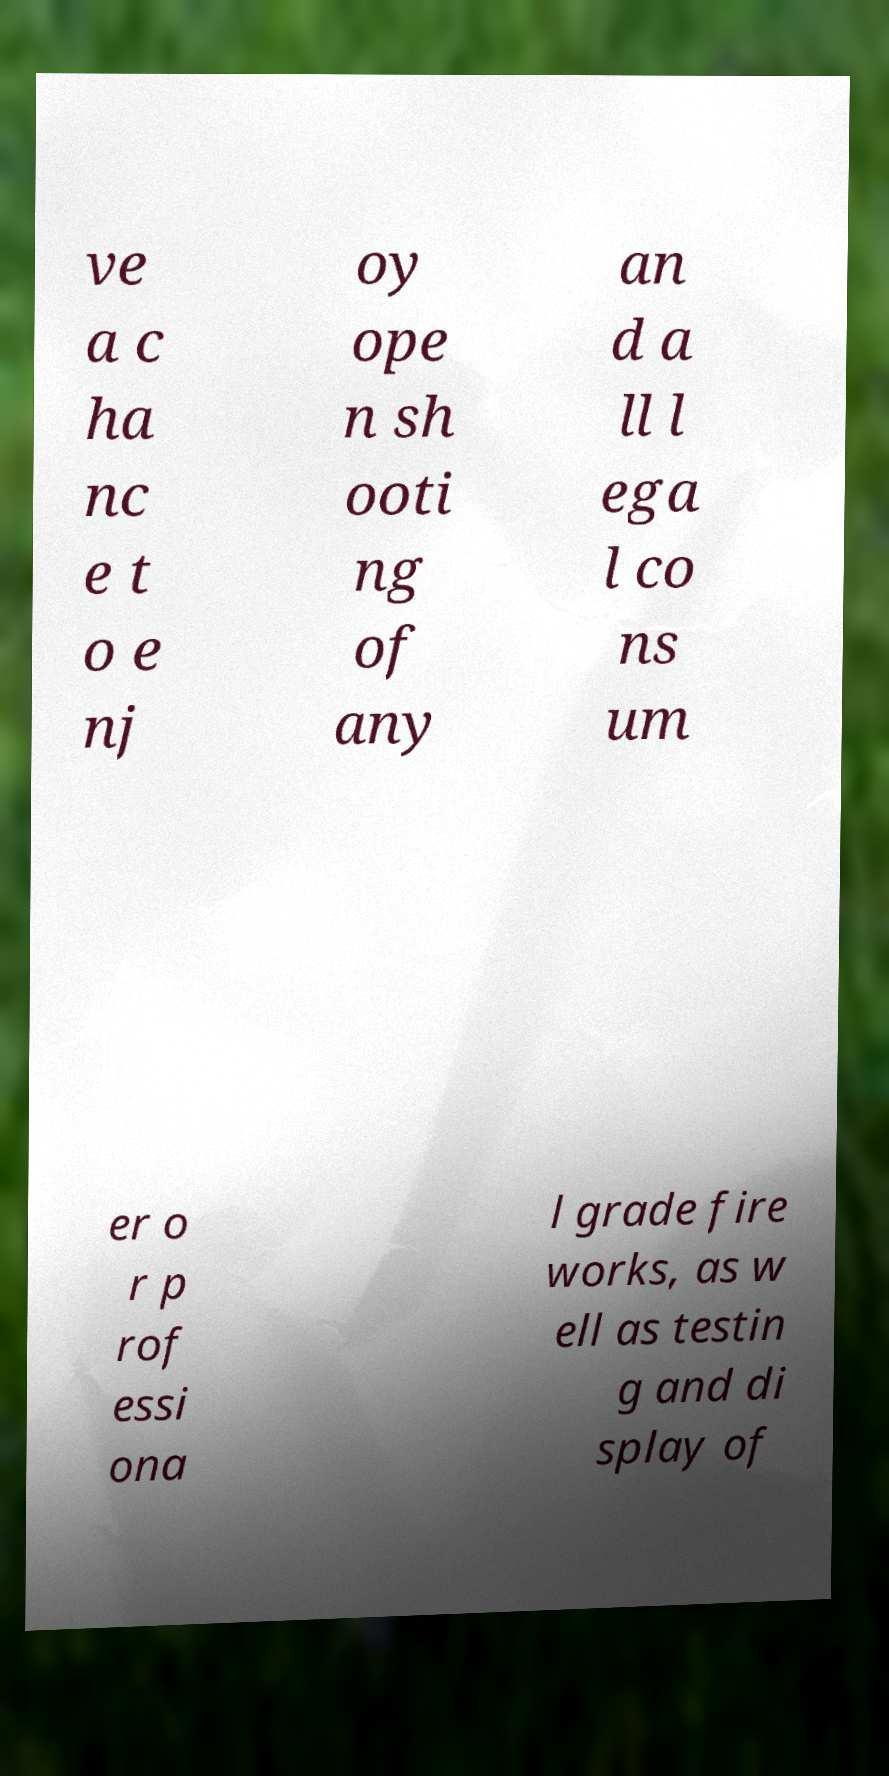What messages or text are displayed in this image? I need them in a readable, typed format. ve a c ha nc e t o e nj oy ope n sh ooti ng of any an d a ll l ega l co ns um er o r p rof essi ona l grade fire works, as w ell as testin g and di splay of 